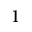Convert formula to latex. <formula><loc_0><loc_0><loc_500><loc_500>1</formula> 